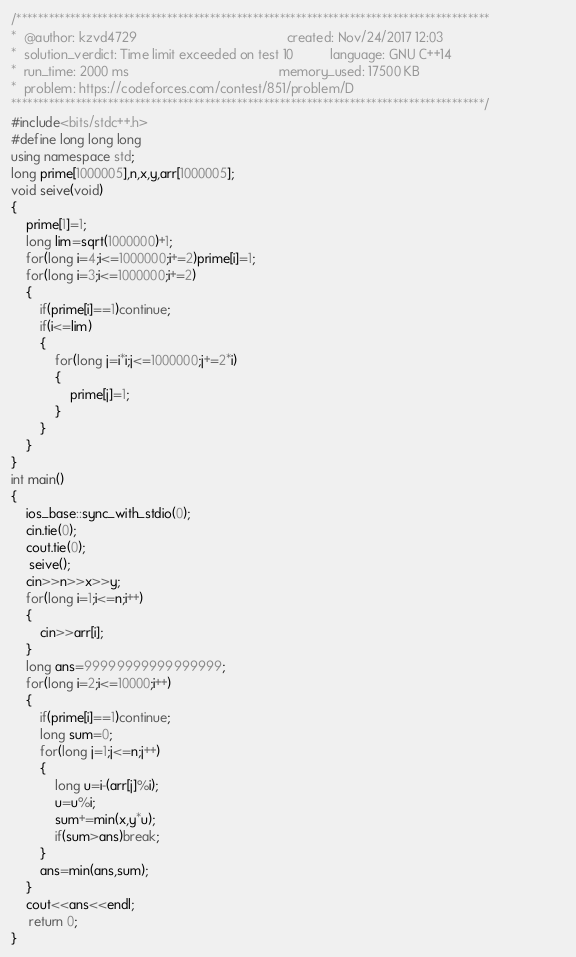<code> <loc_0><loc_0><loc_500><loc_500><_C++_>/****************************************************************************************
*  @author: kzvd4729                                         created: Nov/24/2017 12:03                        
*  solution_verdict: Time limit exceeded on test 10          language: GNU C++14                               
*  run_time: 2000 ms                                         memory_used: 17500 KB                             
*  problem: https://codeforces.com/contest/851/problem/D
****************************************************************************************/
#include<bits/stdc++.h>
#define long long long
using namespace std;
long prime[1000005],n,x,y,arr[1000005];
void seive(void)
{
    prime[1]=1;
    long lim=sqrt(1000000)+1;
    for(long i=4;i<=1000000;i+=2)prime[i]=1;
    for(long i=3;i<=1000000;i+=2)
    {
        if(prime[i]==1)continue;
        if(i<=lim)
        {
            for(long j=i*i;j<=1000000;j+=2*i)
            {
                prime[j]=1;
            }
        }
    }
}
int main()
{
    ios_base::sync_with_stdio(0);
    cin.tie(0);
    cout.tie(0);
     seive();
    cin>>n>>x>>y;
    for(long i=1;i<=n;i++)
    {
        cin>>arr[i];
    }
    long ans=99999999999999999;
    for(long i=2;i<=10000;i++)
    {
        if(prime[i]==1)continue;
        long sum=0;
        for(long j=1;j<=n;j++)
        {
            long u=i-(arr[j]%i);
            u=u%i;
            sum+=min(x,y*u);
            if(sum>ans)break;
        }
        ans=min(ans,sum);
    }
    cout<<ans<<endl;
     return 0;
}</code> 